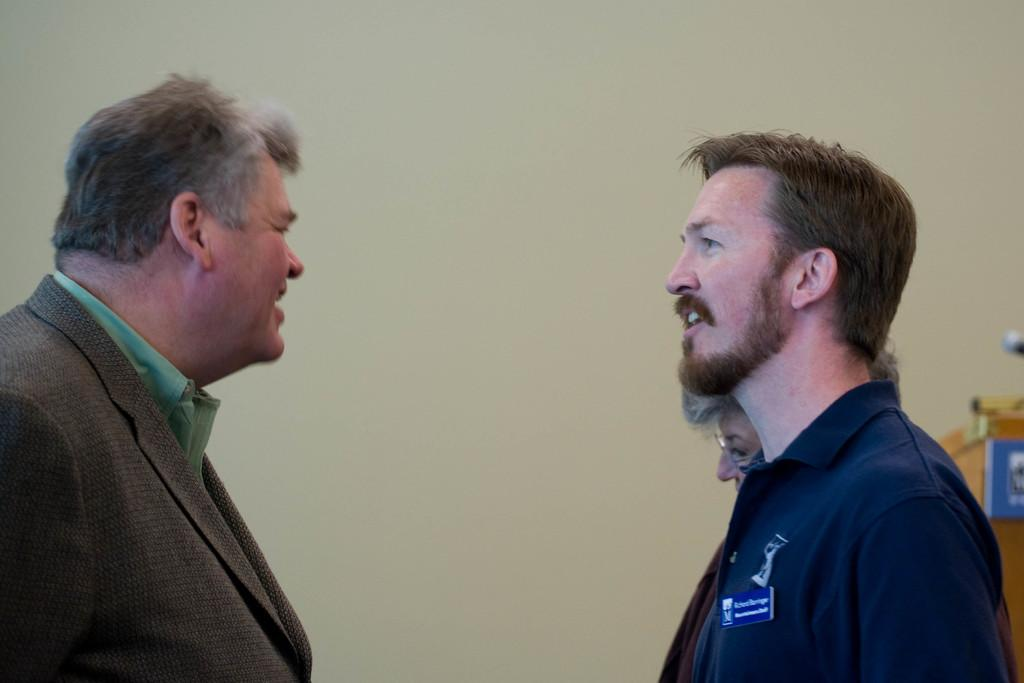How many people are in the image? There are three persons standing in the image. What can be seen on the right side of the image? There appears to be a podium on the right side of the image. What is visible in the background of the image? There is a wall visible in the background of the image. What type of prison is depicted in the image? There is no prison present in the image; it features three persons standing and a podium on the right side. How does the daughter interact with the wall in the image? There is no daughter present in the image, and therefore no interaction with the wall can be observed. 